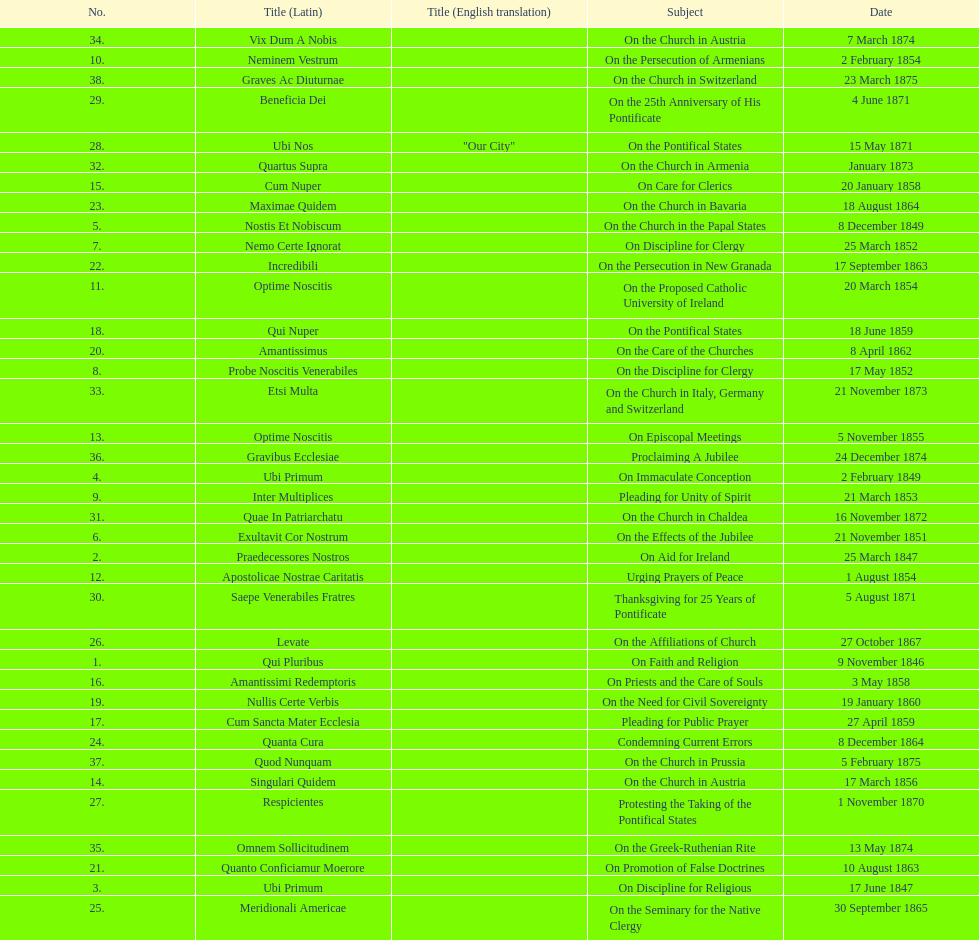Total number of encyclicals on churches . 11. 